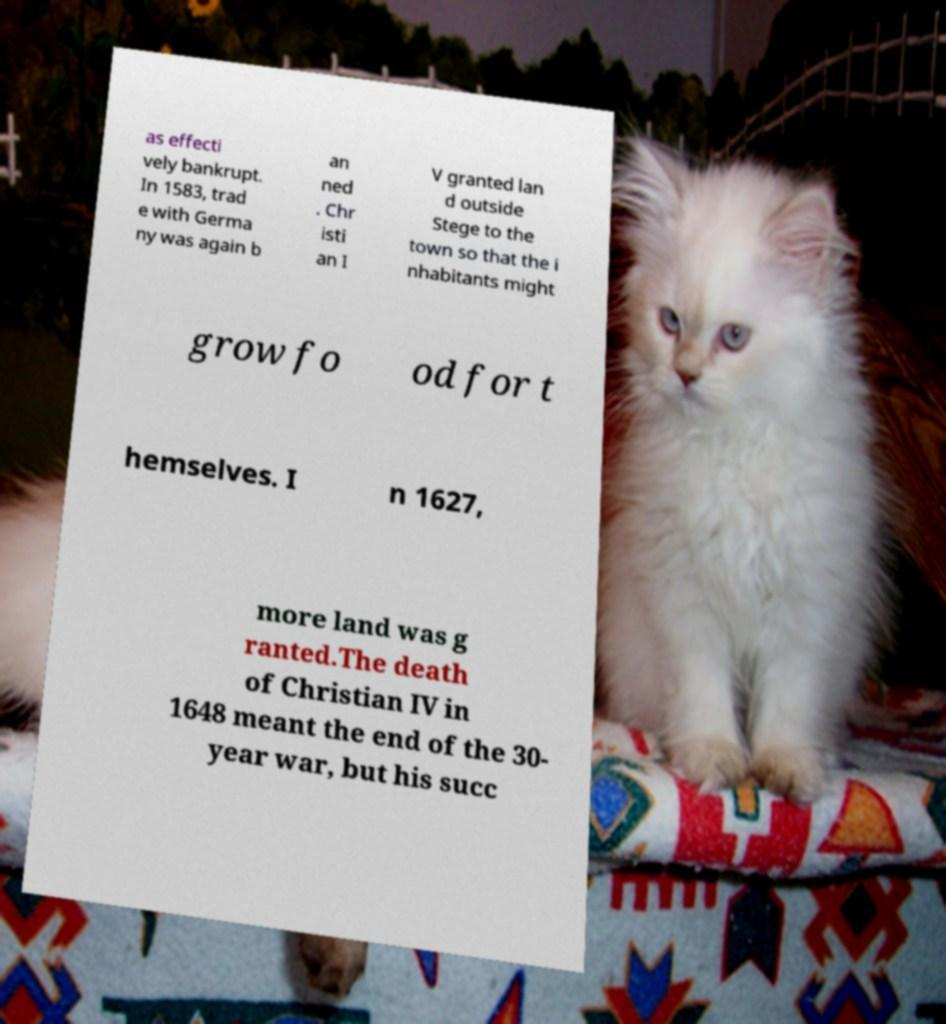I need the written content from this picture converted into text. Can you do that? as effecti vely bankrupt. In 1583, trad e with Germa ny was again b an ned . Chr isti an I V granted lan d outside Stege to the town so that the i nhabitants might grow fo od for t hemselves. I n 1627, more land was g ranted.The death of Christian IV in 1648 meant the end of the 30- year war, but his succ 